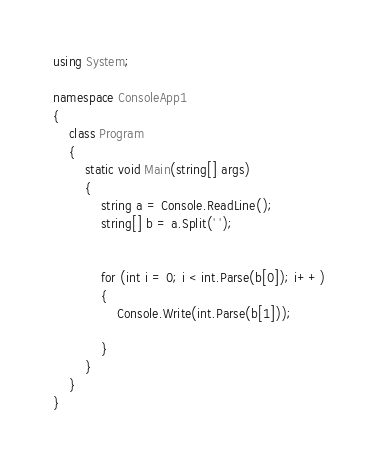Convert code to text. <code><loc_0><loc_0><loc_500><loc_500><_C#_>using System;

namespace ConsoleApp1
{
    class Program
    {
        static void Main(string[] args)
        {
            string a = Console.ReadLine();
            string[] b = a.Split(' ');
            

            for (int i = 0; i < int.Parse(b[0]); i++)
            {
                Console.Write(int.Parse(b[1]));

            }
        }
    }
}</code> 